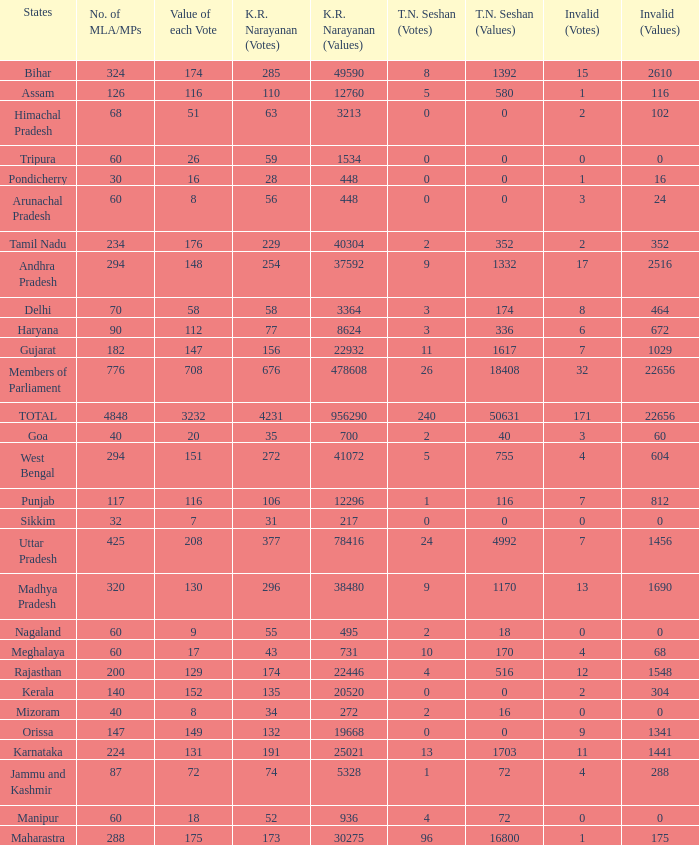Name the k. r. narayanan values for pondicherry 448.0. I'm looking to parse the entire table for insights. Could you assist me with that? {'header': ['States', 'No. of MLA/MPs', 'Value of each Vote', 'K.R. Narayanan (Votes)', 'K.R. Narayanan (Values)', 'T.N. Seshan (Votes)', 'T.N. Seshan (Values)', 'Invalid (Votes)', 'Invalid (Values)'], 'rows': [['Bihar', '324', '174', '285', '49590', '8', '1392', '15', '2610'], ['Assam', '126', '116', '110', '12760', '5', '580', '1', '116'], ['Himachal Pradesh', '68', '51', '63', '3213', '0', '0', '2', '102'], ['Tripura', '60', '26', '59', '1534', '0', '0', '0', '0'], ['Pondicherry', '30', '16', '28', '448', '0', '0', '1', '16'], ['Arunachal Pradesh', '60', '8', '56', '448', '0', '0', '3', '24'], ['Tamil Nadu', '234', '176', '229', '40304', '2', '352', '2', '352'], ['Andhra Pradesh', '294', '148', '254', '37592', '9', '1332', '17', '2516'], ['Delhi', '70', '58', '58', '3364', '3', '174', '8', '464'], ['Haryana', '90', '112', '77', '8624', '3', '336', '6', '672'], ['Gujarat', '182', '147', '156', '22932', '11', '1617', '7', '1029'], ['Members of Parliament', '776', '708', '676', '478608', '26', '18408', '32', '22656'], ['TOTAL', '4848', '3232', '4231', '956290', '240', '50631', '171', '22656'], ['Goa', '40', '20', '35', '700', '2', '40', '3', '60'], ['West Bengal', '294', '151', '272', '41072', '5', '755', '4', '604'], ['Punjab', '117', '116', '106', '12296', '1', '116', '7', '812'], ['Sikkim', '32', '7', '31', '217', '0', '0', '0', '0'], ['Uttar Pradesh', '425', '208', '377', '78416', '24', '4992', '7', '1456'], ['Madhya Pradesh', '320', '130', '296', '38480', '9', '1170', '13', '1690'], ['Nagaland', '60', '9', '55', '495', '2', '18', '0', '0'], ['Meghalaya', '60', '17', '43', '731', '10', '170', '4', '68'], ['Rajasthan', '200', '129', '174', '22446', '4', '516', '12', '1548'], ['Kerala', '140', '152', '135', '20520', '0', '0', '2', '304'], ['Mizoram', '40', '8', '34', '272', '2', '16', '0', '0'], ['Orissa', '147', '149', '132', '19668', '0', '0', '9', '1341'], ['Karnataka', '224', '131', '191', '25021', '13', '1703', '11', '1441'], ['Jammu and Kashmir', '87', '72', '74', '5328', '1', '72', '4', '288'], ['Manipur', '60', '18', '52', '936', '4', '72', '0', '0'], ['Maharastra', '288', '175', '173', '30275', '96', '16800', '1', '175']]} 